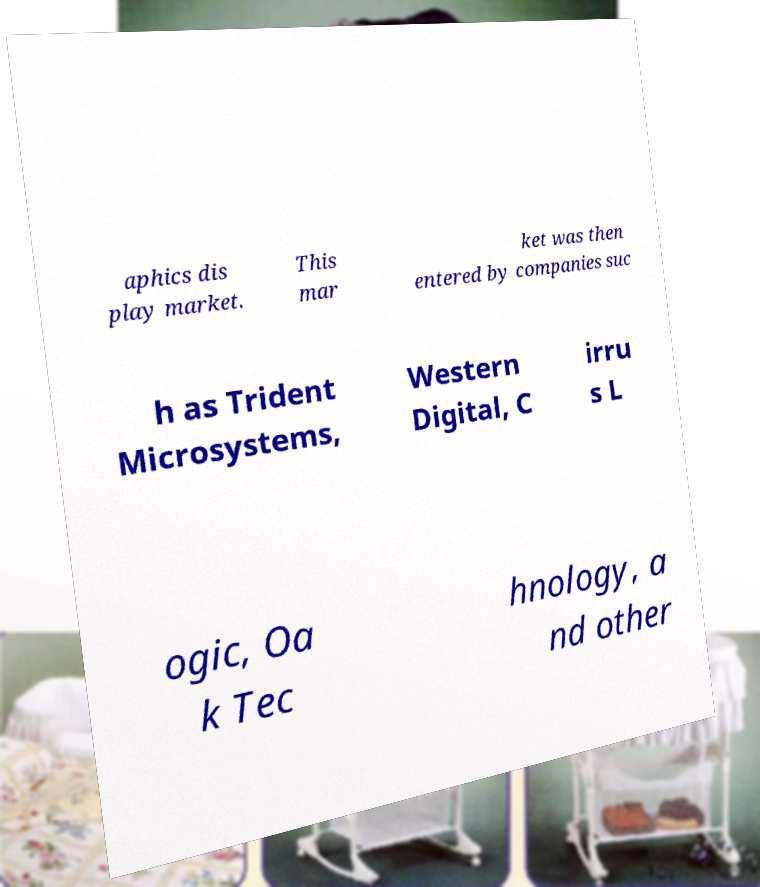Please identify and transcribe the text found in this image. aphics dis play market. This mar ket was then entered by companies suc h as Trident Microsystems, Western Digital, C irru s L ogic, Oa k Tec hnology, a nd other 